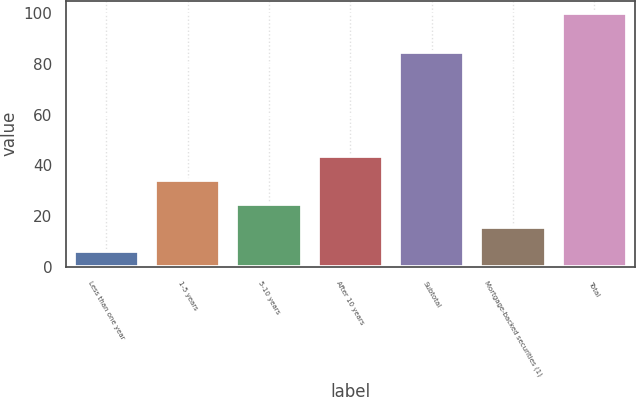<chart> <loc_0><loc_0><loc_500><loc_500><bar_chart><fcel>Less than one year<fcel>1-5 years<fcel>5-10 years<fcel>After 10 years<fcel>Subtotal<fcel>Mortgage-backed securities (1)<fcel>Total<nl><fcel>6.2<fcel>34.34<fcel>24.96<fcel>43.72<fcel>84.6<fcel>15.58<fcel>100<nl></chart> 